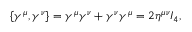Convert formula to latex. <formula><loc_0><loc_0><loc_500><loc_500>\{ \gamma ^ { \mu } , \gamma ^ { \nu } \} = \gamma ^ { \mu } \gamma ^ { \nu } + \gamma ^ { \nu } \gamma ^ { \mu } = 2 \eta ^ { \mu \nu } I _ { 4 } ,</formula> 